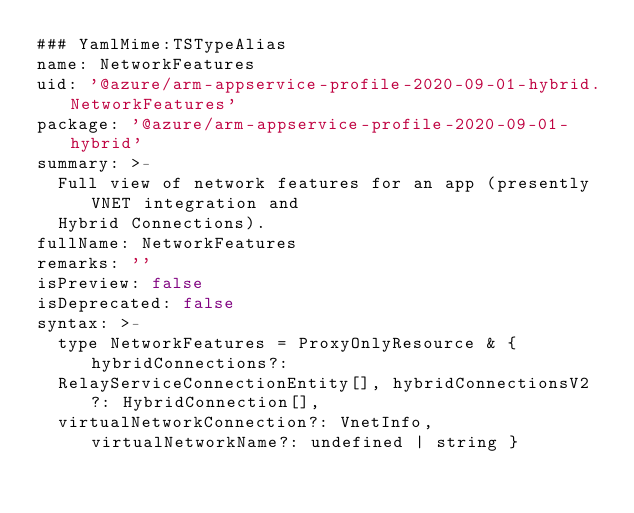<code> <loc_0><loc_0><loc_500><loc_500><_YAML_>### YamlMime:TSTypeAlias
name: NetworkFeatures
uid: '@azure/arm-appservice-profile-2020-09-01-hybrid.NetworkFeatures'
package: '@azure/arm-appservice-profile-2020-09-01-hybrid'
summary: >-
  Full view of network features for an app (presently VNET integration and
  Hybrid Connections).
fullName: NetworkFeatures
remarks: ''
isPreview: false
isDeprecated: false
syntax: >-
  type NetworkFeatures = ProxyOnlyResource & { hybridConnections?:
  RelayServiceConnectionEntity[], hybridConnectionsV2?: HybridConnection[],
  virtualNetworkConnection?: VnetInfo, virtualNetworkName?: undefined | string }
</code> 